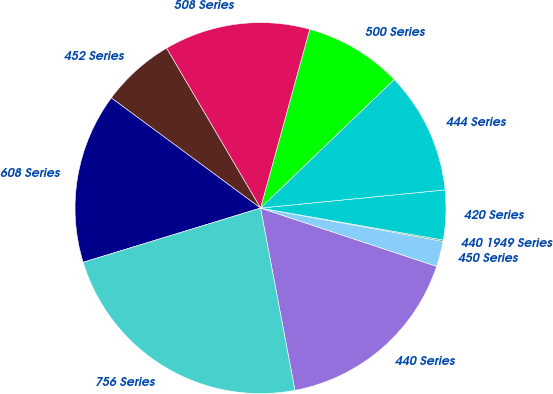Convert chart to OTSL. <chart><loc_0><loc_0><loc_500><loc_500><pie_chart><fcel>440 Series<fcel>450 Series<fcel>440 1949 Series<fcel>420 Series<fcel>444 Series<fcel>500 Series<fcel>508 Series<fcel>452 Series<fcel>608 Series<fcel>756 Series<nl><fcel>16.94%<fcel>2.22%<fcel>0.11%<fcel>4.32%<fcel>10.63%<fcel>8.53%<fcel>12.73%<fcel>6.42%<fcel>14.84%<fcel>23.25%<nl></chart> 